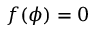<formula> <loc_0><loc_0><loc_500><loc_500>f ( \phi ) = 0</formula> 